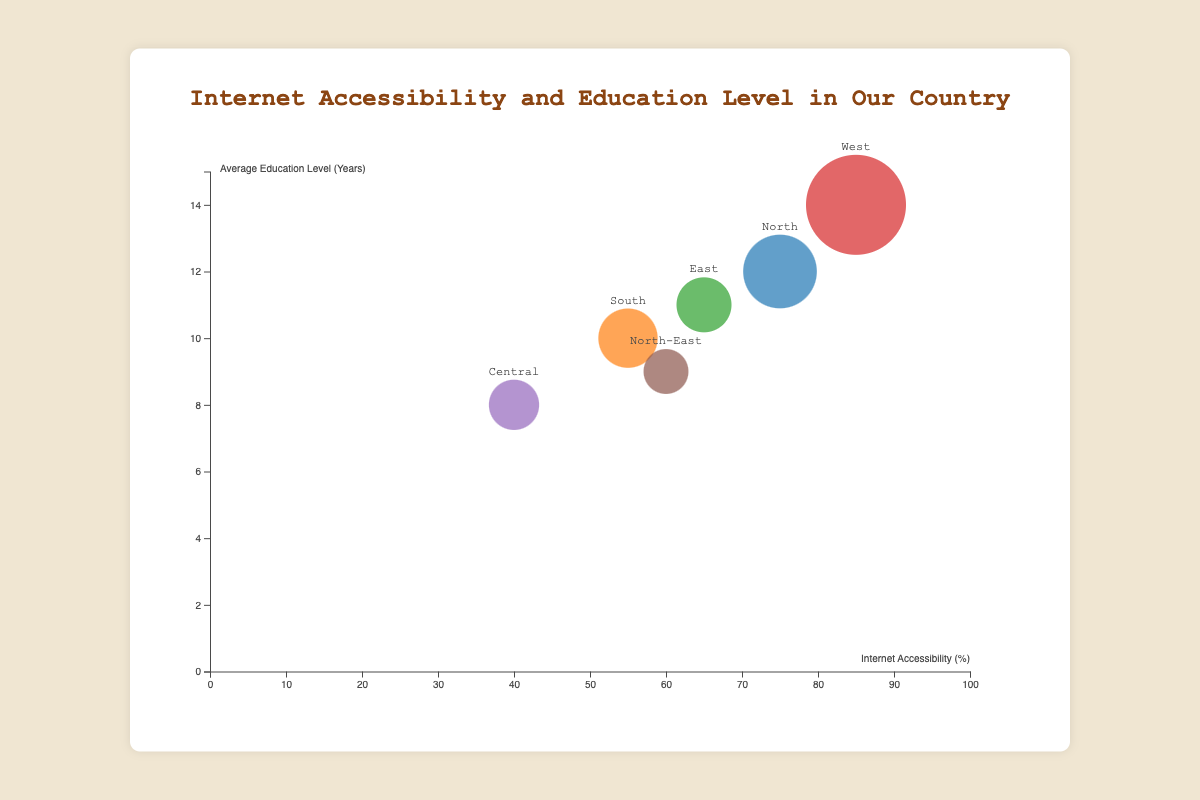What's the highest average education level recorded among the regions? The highest average education level can be seen where the vertical position of the bubble is the highest on the y-axis, which is 14 years in the West region.
Answer: 14 years Which region has the smallest population? The smallest population is represented by the smallest bubble on the chart; the North-East region has the smallest population of 15,000.
Answer: North-East What's the median internet accessibility percentage across all regions? The accessibility percentages are 75, 55, 65, 85, 40, and 60. Arranging them in ascending order: 40, 55, 60, 65, 75, 85, the median value is the average of 60 and 65, so (60 + 65) / 2 = 62.5.
Answer: 62.5% Which region has the highest bubble size, and what does it represent? The largest bubble represents the population, which is found in the West region with a population of 100,000.
Answer: West (population of 100,000) Is there a correlation between internet accessibility and education levels across the regions? By observing the horizontal and vertical positions of the bubbles, regions with higher internet accessibility tend to have higher average education levels (e.g., West and North). Conversely, regions with lower internet accessibility have lower education levels (e.g., Central and North-East).
Answer: Yes Compare the internet accessibility of the North and South regions. The North region has an internet accessibility percentage of 75%, while the South has 55%; the North has higher internet accessibility.
Answer: North has higher internet accessibility What is the combined population of the regions with internet accessibility over 60%? Regions with internet accessibility over 60% are North (75%, 50,000), West (85%, 100,000), and East (65%, 25,000). Their combined population is 50,000 + 100,000 + 25,000 = 175,000.
Answer: 175,000 Which region has internet accessibility closest to the median value, and what is that region's average education level? The median internet accessibility percentage is 62.5%. The East region with 65% is closest to this value. The East region's average education level is 11 years.
Answer: East (11 years) Describe the relationship between bubble size and population in this chart. Larger bubbles represent greater population sizes. For example, the largest bubble represents the West region with the highest population of 100,000, while the smallest bubble represents the North-East region with a population of 15,000.
Answer: Larger bubbles = greater population 